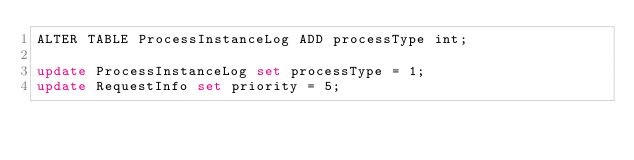<code> <loc_0><loc_0><loc_500><loc_500><_SQL_>ALTER TABLE ProcessInstanceLog ADD processType int;

update ProcessInstanceLog set processType = 1;
update RequestInfo set priority = 5;</code> 